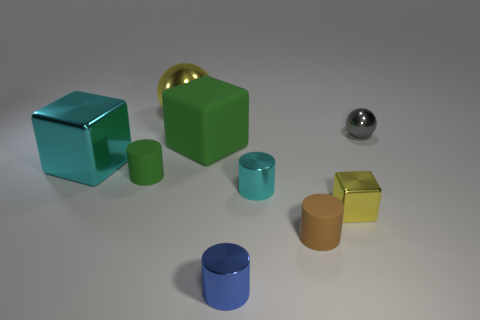How would you describe the lighting and shadows in the scene? The lighting in the scene is soft and diffused, coming from the upper right direction. It casts gentle shadows to the lower left of the objects, contributing to a three-dimensional effect and suggesting a calm, indoor setting. The strength and angle of the shadows indicate a single light source, which could be artificial given the indoor appearance.  Can you infer the time of day from the image? It's not possible to determine the exact time of day from the image as there are no windows or natural light indicators. The lighting appears artificial, which could mean the image was taken indoors at any time. 